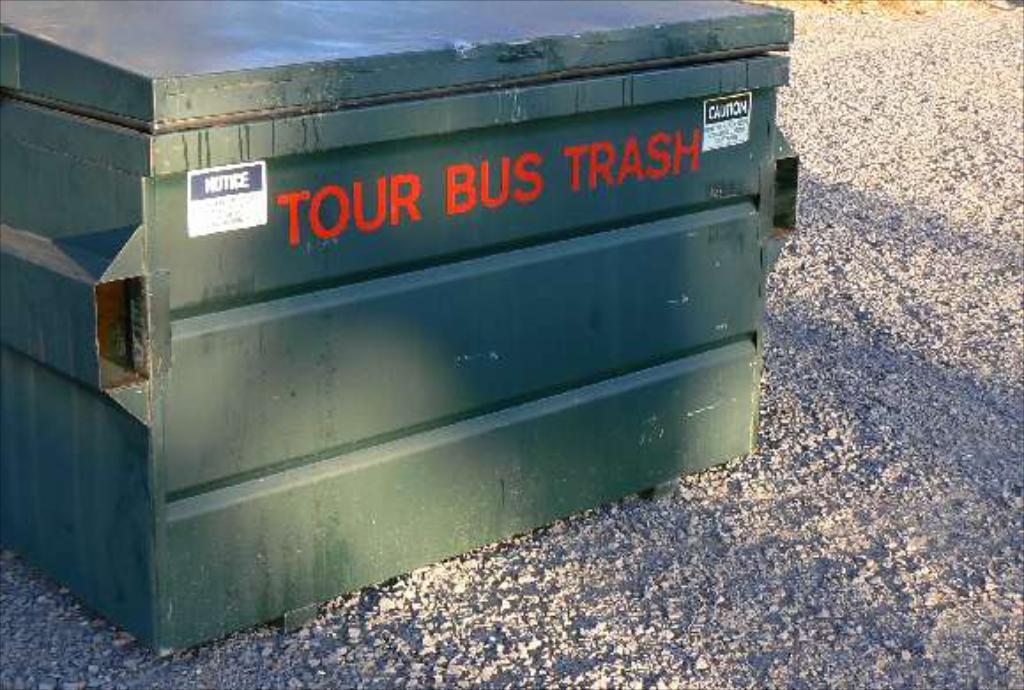Provide a one-sentence caption for the provided image. Tour Bus Trash is painted onto the side of this dumpster. 